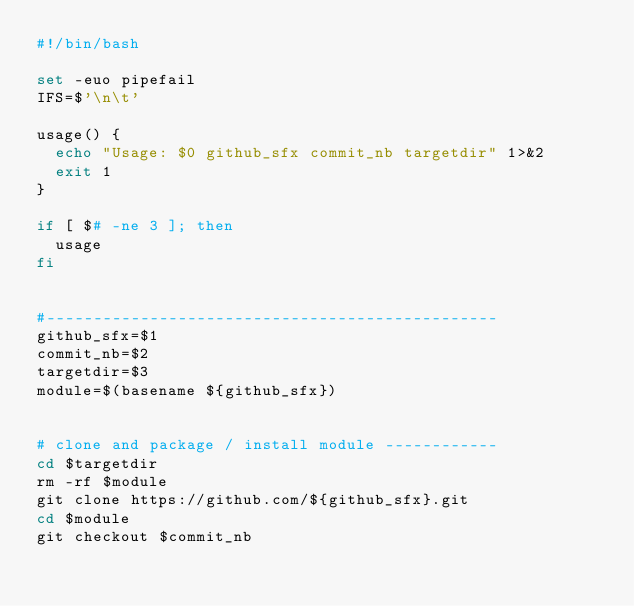<code> <loc_0><loc_0><loc_500><loc_500><_Bash_>#!/bin/bash

set -euo pipefail
IFS=$'\n\t'

usage() {
  echo "Usage: $0 github_sfx commit_nb targetdir" 1>&2
  exit 1
}

if [ $# -ne 3 ]; then
  usage
fi


#------------------------------------------------
github_sfx=$1
commit_nb=$2
targetdir=$3
module=$(basename ${github_sfx})


# clone and package / install module ------------
cd $targetdir
rm -rf $module
git clone https://github.com/${github_sfx}.git
cd $module
git checkout $commit_nb
</code> 